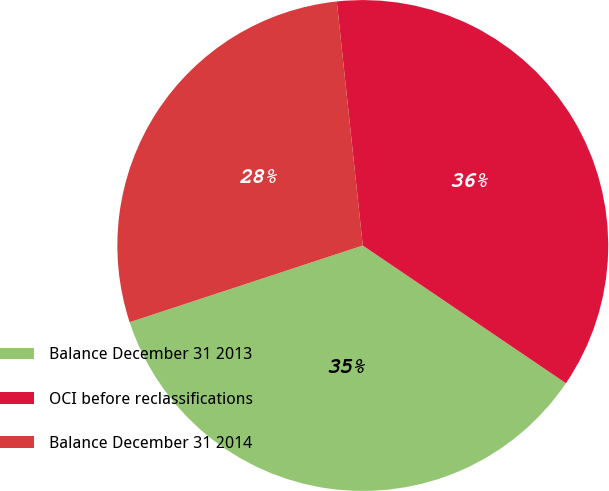<chart> <loc_0><loc_0><loc_500><loc_500><pie_chart><fcel>Balance December 31 2013<fcel>OCI before reclassifications<fcel>Balance December 31 2014<nl><fcel>35.46%<fcel>36.17%<fcel>28.37%<nl></chart> 